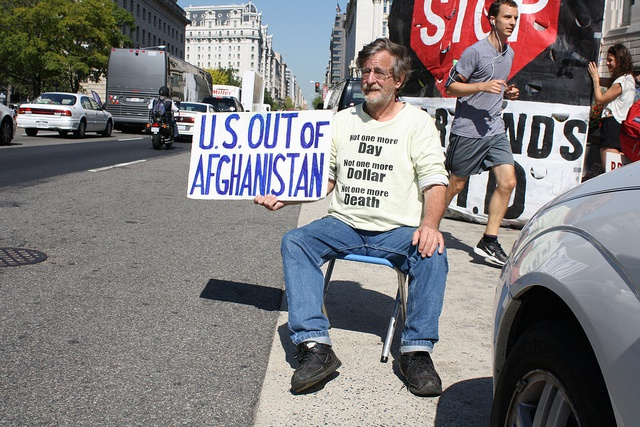Describe the objects in this image and their specific colors. I can see car in darkgreen, black, darkgray, gray, and lightgray tones, people in darkgreen, ivory, gray, and black tones, people in darkgreen, darkgray, black, gray, and tan tones, stop sign in darkgreen, brown, lightgray, and salmon tones, and bus in darkgreen, gray, darkgray, and black tones in this image. 